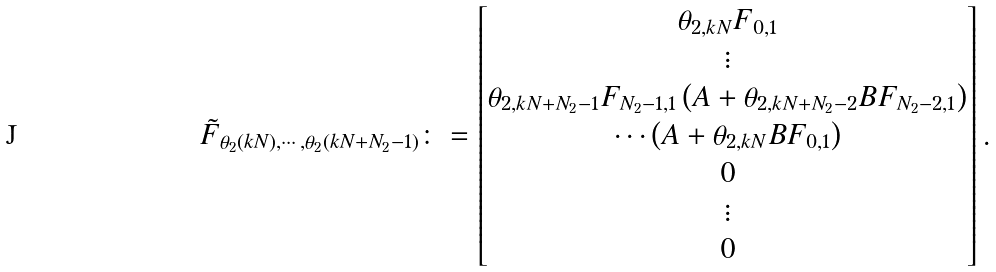<formula> <loc_0><loc_0><loc_500><loc_500>& \tilde { F } _ { \theta _ { 2 } ( k N ) , \cdots , \theta _ { 2 } ( k N + N _ { 2 } - 1 ) } \colon = \begin{bmatrix} \theta _ { 2 , k N } F _ { 0 , 1 } \\ \vdots \\ \theta _ { 2 , k N + N _ { 2 } - 1 } F _ { N _ { 2 } - 1 , 1 } \left ( A + \theta _ { 2 , k N + N _ { 2 } - 2 } B F _ { N _ { 2 } - 2 , 1 } \right ) \\ \cdots \left ( A + \theta _ { 2 , k N } B F _ { 0 , 1 } \right ) \\ 0 \\ \vdots \\ 0 \end{bmatrix} .</formula> 